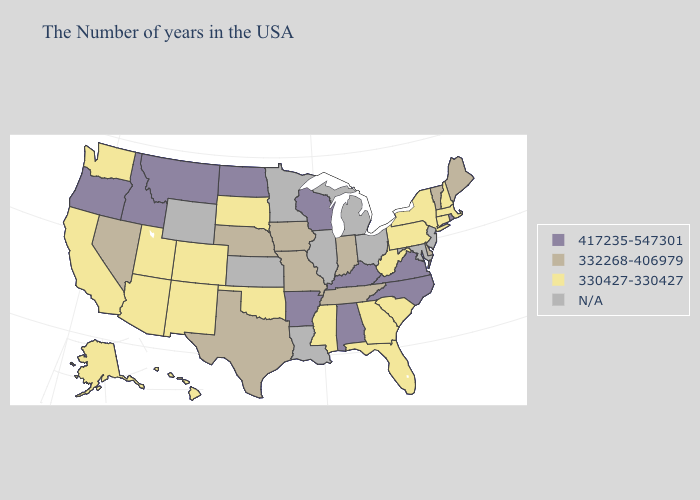Does the first symbol in the legend represent the smallest category?
Concise answer only. No. What is the highest value in states that border Vermont?
Keep it brief. 330427-330427. Name the states that have a value in the range N/A?
Be succinct. New Jersey, Maryland, Ohio, Michigan, Illinois, Louisiana, Minnesota, Kansas, Wyoming. Does South Carolina have the highest value in the South?
Give a very brief answer. No. Among the states that border Oregon , which have the highest value?
Keep it brief. Idaho. What is the value of Montana?
Quick response, please. 417235-547301. Name the states that have a value in the range N/A?
Answer briefly. New Jersey, Maryland, Ohio, Michigan, Illinois, Louisiana, Minnesota, Kansas, Wyoming. Does Mississippi have the lowest value in the South?
Concise answer only. Yes. Is the legend a continuous bar?
Short answer required. No. Is the legend a continuous bar?
Concise answer only. No. Does Maine have the lowest value in the Northeast?
Give a very brief answer. No. What is the value of Maryland?
Keep it brief. N/A. 